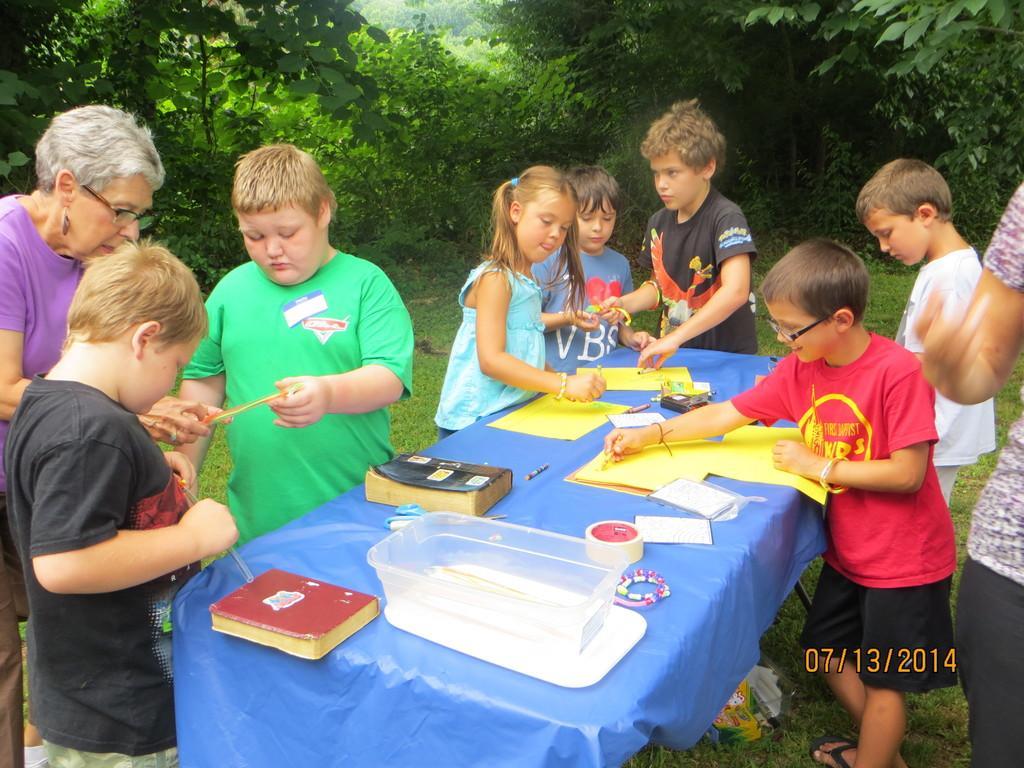Could you give a brief overview of what you see in this image? In this image there is a table and we can see books, papers, bowl, tape, pen and some objects placed on the table. There are people. At the bottom there is grass. In the background there are trees. 